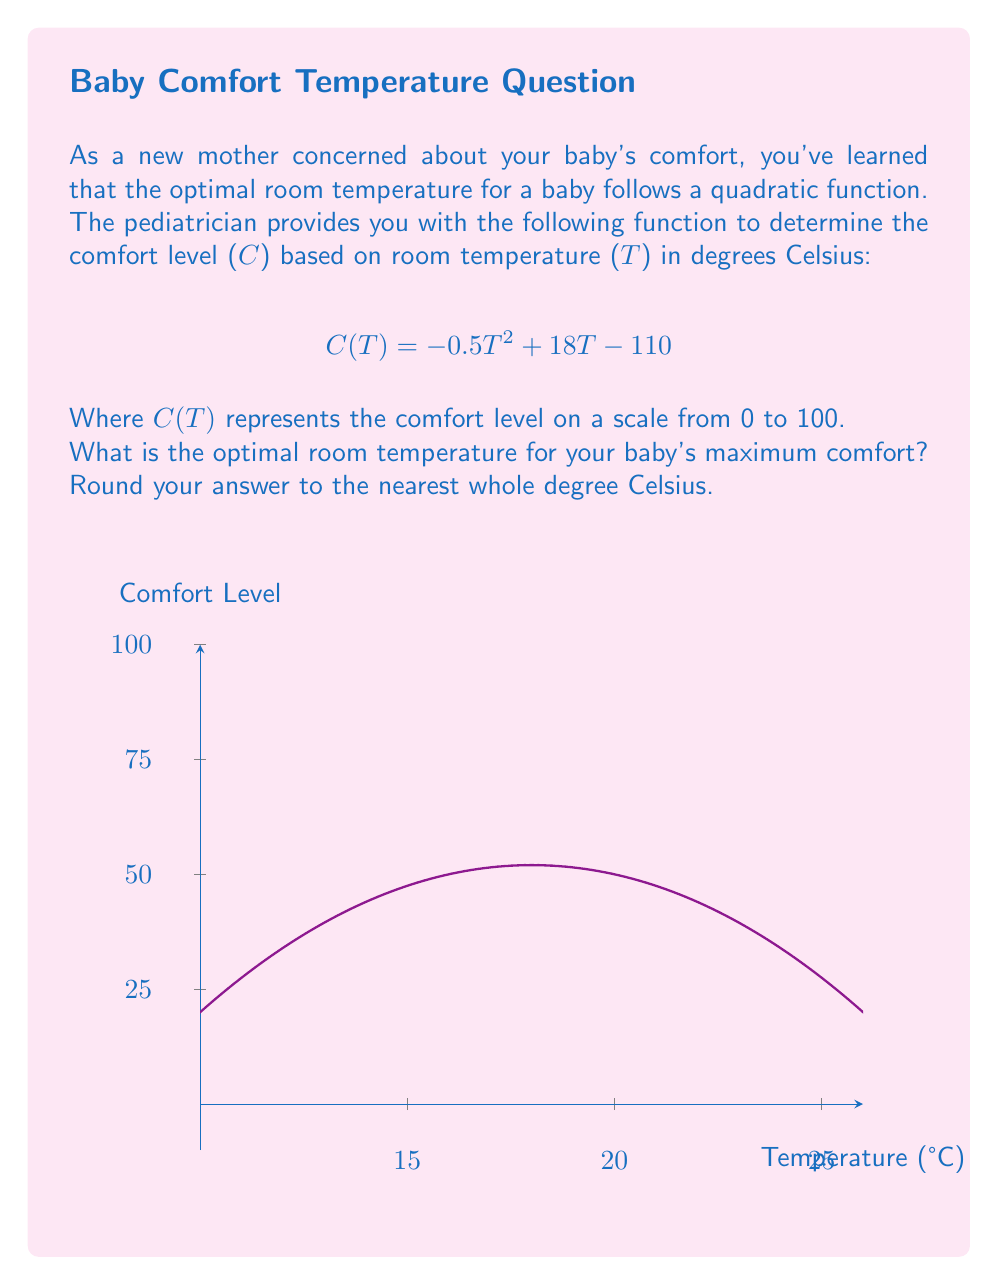Give your solution to this math problem. Let's approach this step-by-step:

1) The comfort level C is a function of temperature T, given by the quadratic function:
   $$C(T) = -0.5T^2 + 18T - 110$$

2) To find the maximum comfort level, we need to find the vertex of this parabola. The vertex represents the highest point of the parabola, which corresponds to the optimal temperature.

3) For a quadratic function in the form $f(x) = ax^2 + bx + c$, the x-coordinate of the vertex is given by $x = -\frac{b}{2a}$.

4) In our function, $a = -0.5$, $b = 18$, and $c = -110$.

5) Substituting these values:
   $$T = -\frac{18}{2(-0.5)} = -\frac{18}{-1} = 18$$

6) Therefore, the optimal temperature is 18°C.

7) To verify, we can calculate the comfort levels for temperatures around 18°C:
   
   At 17°C: $C(17) = -0.5(17)^2 + 18(17) - 110 = 98.5$
   At 18°C: $C(18) = -0.5(18)^2 + 18(18) - 110 = 102$
   At 19°C: $C(19) = -0.5(19)^2 + 18(19) - 110 = 98.5$

   This confirms that 18°C gives the highest comfort level.

8) The question asks to round to the nearest whole degree, but 18°C is already a whole number, so no rounding is necessary.
Answer: 18°C 